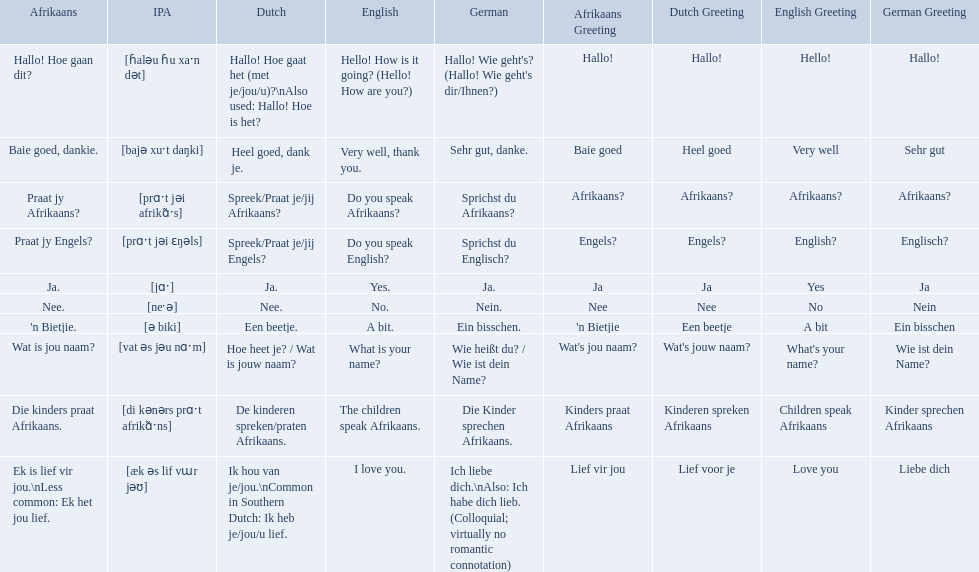What are the listed afrikaans phrases? Hallo! Hoe gaan dit?, Baie goed, dankie., Praat jy Afrikaans?, Praat jy Engels?, Ja., Nee., 'n Bietjie., Wat is jou naam?, Die kinders praat Afrikaans., Ek is lief vir jou.\nLess common: Ek het jou lief. Which is die kinders praat afrikaans? Die kinders praat Afrikaans. What is its german translation? Die Kinder sprechen Afrikaans. Would you be able to parse every entry in this table? {'header': ['Afrikaans', 'IPA', 'Dutch', 'English', 'German', 'Afrikaans Greeting', 'Dutch Greeting', 'English Greeting', 'German Greeting'], 'rows': [['Hallo! Hoe gaan dit?', '[ɦaləu ɦu xaˑn dət]', 'Hallo! Hoe gaat het (met je/jou/u)?\\nAlso used: Hallo! Hoe is het?', 'Hello! How is it going? (Hello! How are you?)', "Hallo! Wie geht's? (Hallo! Wie geht's dir/Ihnen?)", 'Hallo!', 'Hallo!', 'Hello!', 'Hallo!'], ['Baie goed, dankie.', '[bajə xuˑt daŋki]', 'Heel goed, dank je.', 'Very well, thank you.', 'Sehr gut, danke.', 'Baie goed', 'Heel goed', 'Very well', 'Sehr gut'], ['Praat jy Afrikaans?', '[prɑˑt jəi afrikɑ̃ˑs]', 'Spreek/Praat je/jij Afrikaans?', 'Do you speak Afrikaans?', 'Sprichst du Afrikaans?', 'Afrikaans?', 'Afrikaans?', 'Afrikaans?', 'Afrikaans?'], ['Praat jy Engels?', '[prɑˑt jəi ɛŋəls]', 'Spreek/Praat je/jij Engels?', 'Do you speak English?', 'Sprichst du Englisch?', 'Engels?', 'Engels?', 'English?', 'Englisch?'], ['Ja.', '[jɑˑ]', 'Ja.', 'Yes.', 'Ja.', 'Ja', 'Ja', 'Yes', 'Ja'], ['Nee.', '[neˑə]', 'Nee.', 'No.', 'Nein.', 'Nee', 'Nee', 'No', 'Nein'], ["'n Bietjie.", '[ə biki]', 'Een beetje.', 'A bit.', 'Ein bisschen.', "'n Bietjie", 'Een beetje', 'A bit', 'Ein bisschen'], ['Wat is jou naam?', '[vat əs jəu nɑˑm]', 'Hoe heet je? / Wat is jouw naam?', 'What is your name?', 'Wie heißt du? / Wie ist dein Name?', "Wat's jou naam?", "Wat's jouw naam?", "What's your name?", 'Wie ist dein Name?'], ['Die kinders praat Afrikaans.', '[di kənərs prɑˑt afrikɑ̃ˑns]', 'De kinderen spreken/praten Afrikaans.', 'The children speak Afrikaans.', 'Die Kinder sprechen Afrikaans.', 'Kinders praat Afrikaans', 'Kinderen spreken Afrikaans', 'Children speak Afrikaans', 'Kinder sprechen Afrikaans'], ['Ek is lief vir jou.\\nLess common: Ek het jou lief.', '[æk əs lif vɯr jəʊ]', 'Ik hou van je/jou.\\nCommon in Southern Dutch: Ik heb je/jou/u lief.', 'I love you.', 'Ich liebe dich.\\nAlso: Ich habe dich lieb. (Colloquial; virtually no romantic connotation)', 'Lief vir jou', 'Lief voor je', 'Love you', 'Liebe dich']]} How do you say do you speak english in german? Sprichst du Englisch?. What about do you speak afrikaanss? in afrikaans? Praat jy Afrikaans?. How do you say hello! how is it going? in afrikaans? Hallo! Hoe gaan dit?. How do you say very well, thank you in afrikaans? Baie goed, dankie. How would you say do you speak afrikaans? in afrikaans? Praat jy Afrikaans?. 